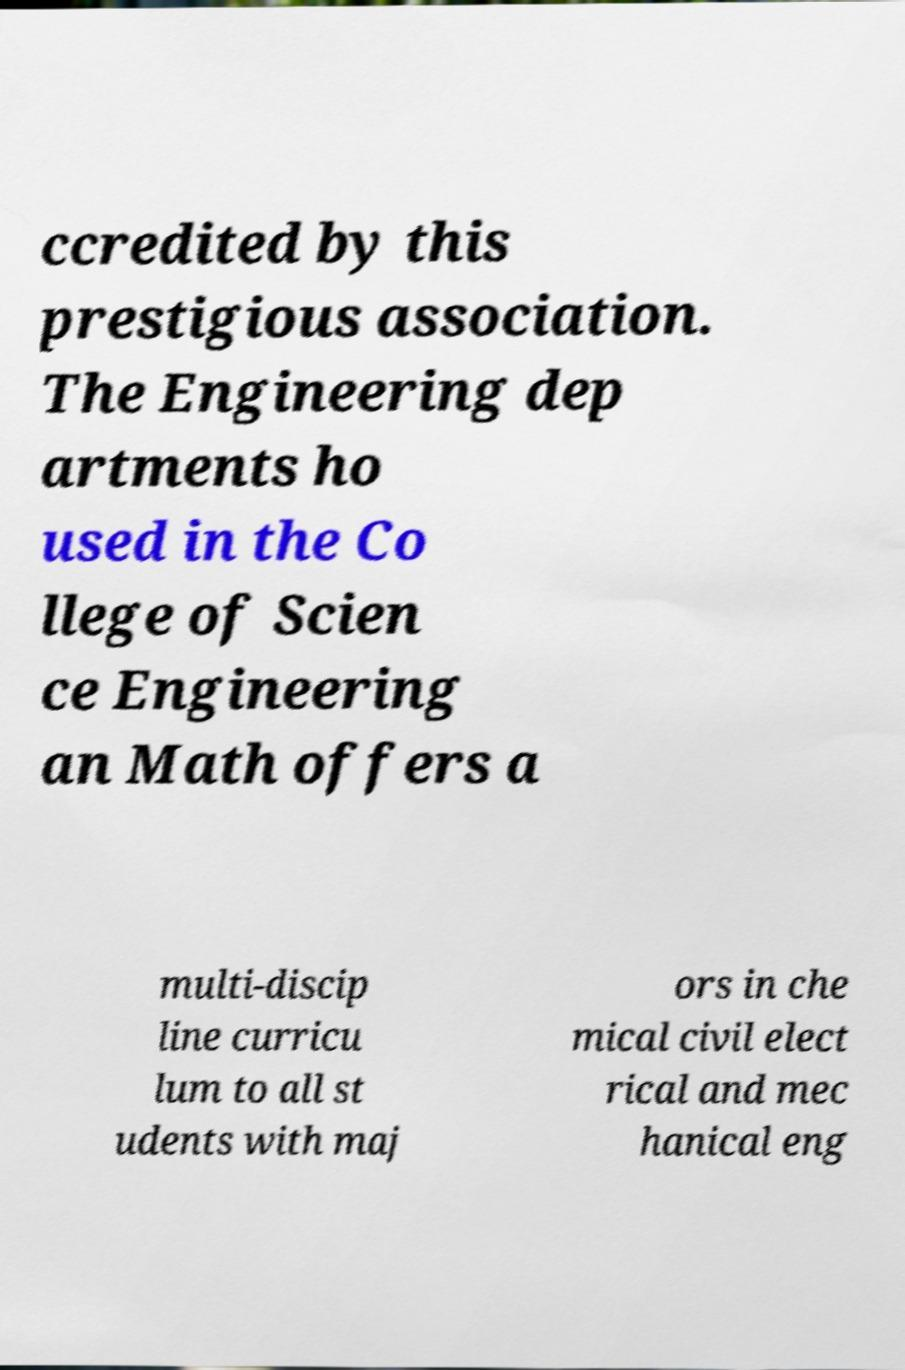There's text embedded in this image that I need extracted. Can you transcribe it verbatim? ccredited by this prestigious association. The Engineering dep artments ho used in the Co llege of Scien ce Engineering an Math offers a multi-discip line curricu lum to all st udents with maj ors in che mical civil elect rical and mec hanical eng 